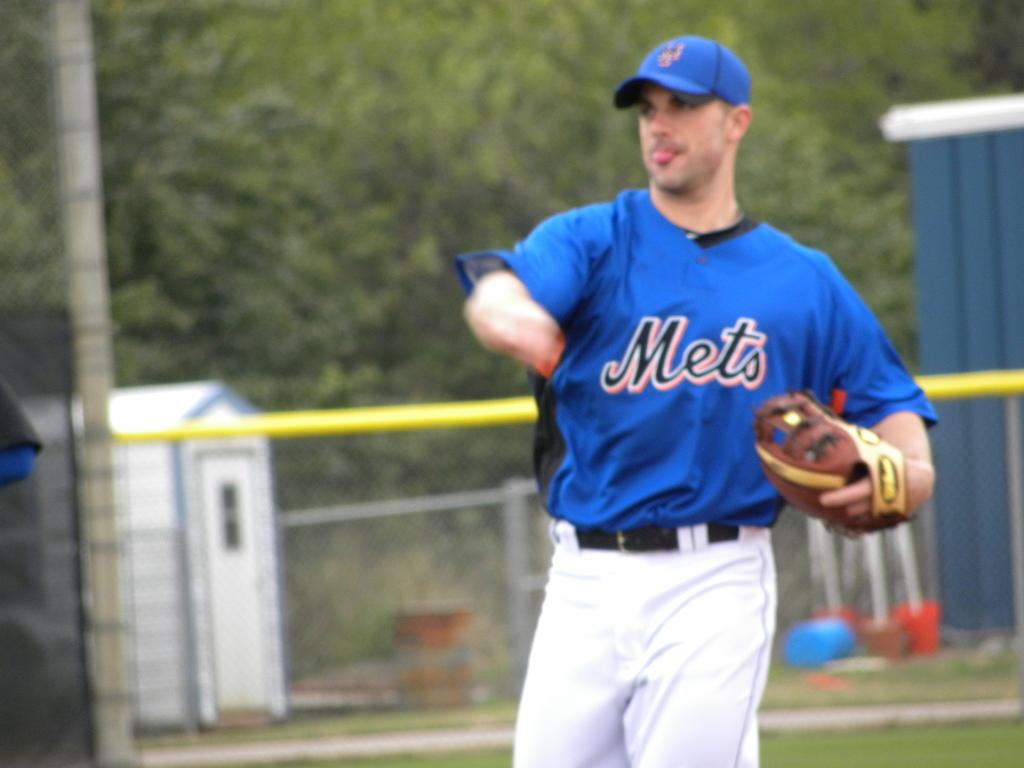Provide a one-sentence caption for the provided image. A ball player pitches for the Mets on the field. 